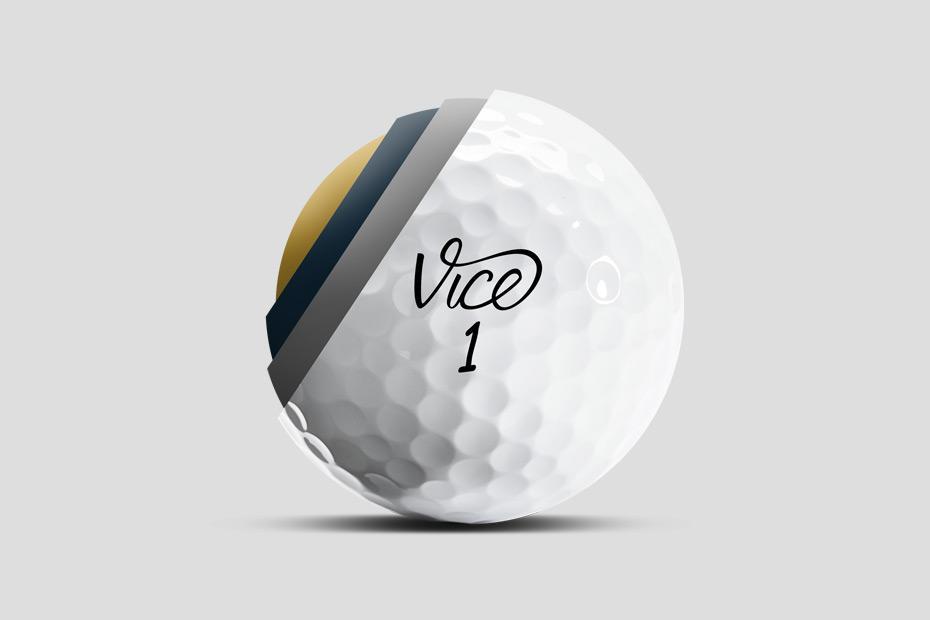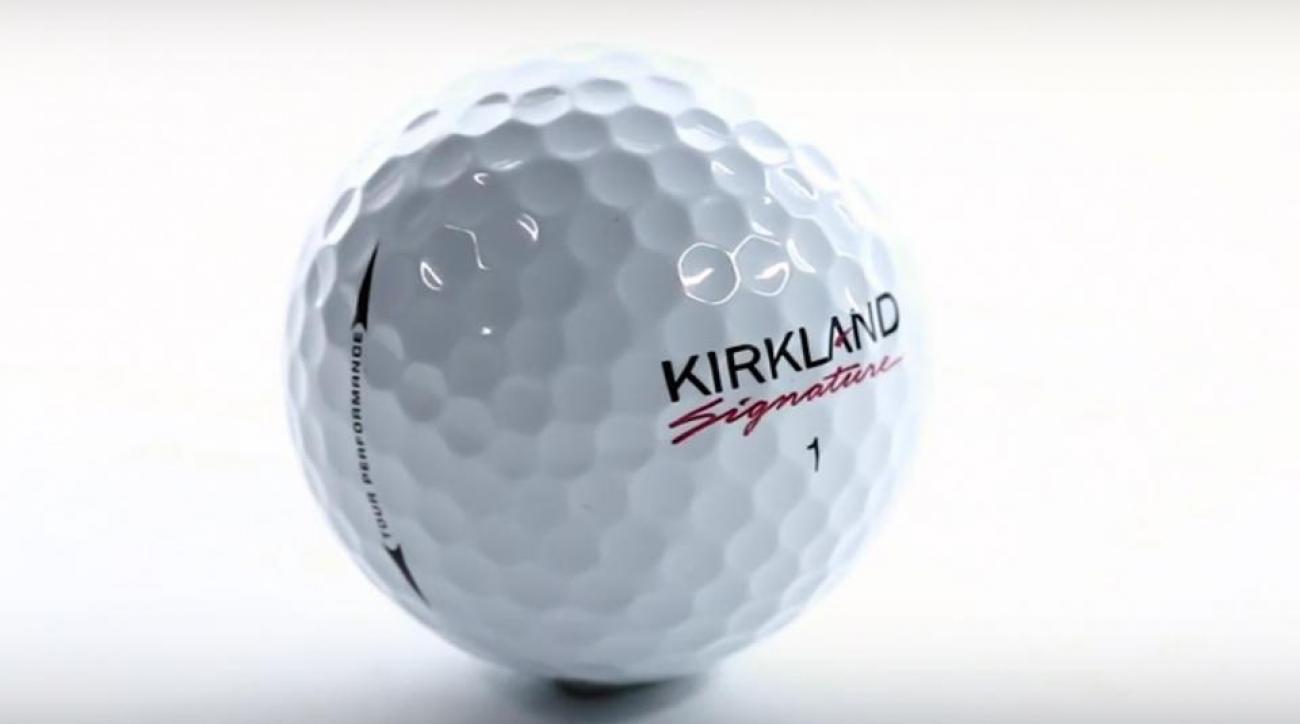The first image is the image on the left, the second image is the image on the right. Analyze the images presented: Is the assertion "There are three golf balls" valid? Answer yes or no. No. 